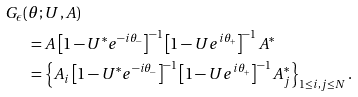Convert formula to latex. <formula><loc_0><loc_0><loc_500><loc_500>G _ { \epsilon } ( & \theta ; U , A ) \\ & = A \left [ 1 - U ^ { * } e ^ { - i \theta _ { - } } \right ] ^ { - 1 } \left [ 1 - U e ^ { i \theta _ { + } } \right ] ^ { - 1 } A ^ { * } \\ & = \left \{ A _ { i } \left [ 1 - U ^ { * } e ^ { - i \theta _ { - } } \right ] ^ { - 1 } \left [ 1 - U e ^ { i \theta _ { + } } \right ] ^ { - 1 } A _ { j } ^ { * } \right \} _ { 1 \leq i , j \leq N } \text {.}</formula> 